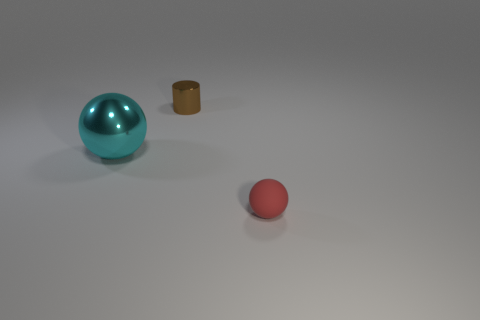Is there anything else that is the same material as the red ball?
Offer a terse response. No. What number of shiny objects are either cyan objects or big green balls?
Offer a very short reply. 1. There is a object that is in front of the big object; is it the same shape as the metal object left of the brown metal thing?
Give a very brief answer. Yes. There is a object that is behind the rubber thing and on the right side of the cyan thing; what color is it?
Provide a succinct answer. Brown. Is the size of the shiny object that is behind the cyan ball the same as the sphere that is right of the big cyan metallic thing?
Keep it short and to the point. Yes. What number of small things are purple cylinders or matte spheres?
Your answer should be compact. 1. Does the tiny object that is behind the matte thing have the same material as the big ball?
Keep it short and to the point. Yes. The metal cylinder that is to the right of the big cyan shiny sphere is what color?
Keep it short and to the point. Brown. Is there a red ball that has the same size as the brown shiny cylinder?
Ensure brevity in your answer.  Yes. There is a red ball that is the same size as the brown object; what is its material?
Keep it short and to the point. Rubber. 